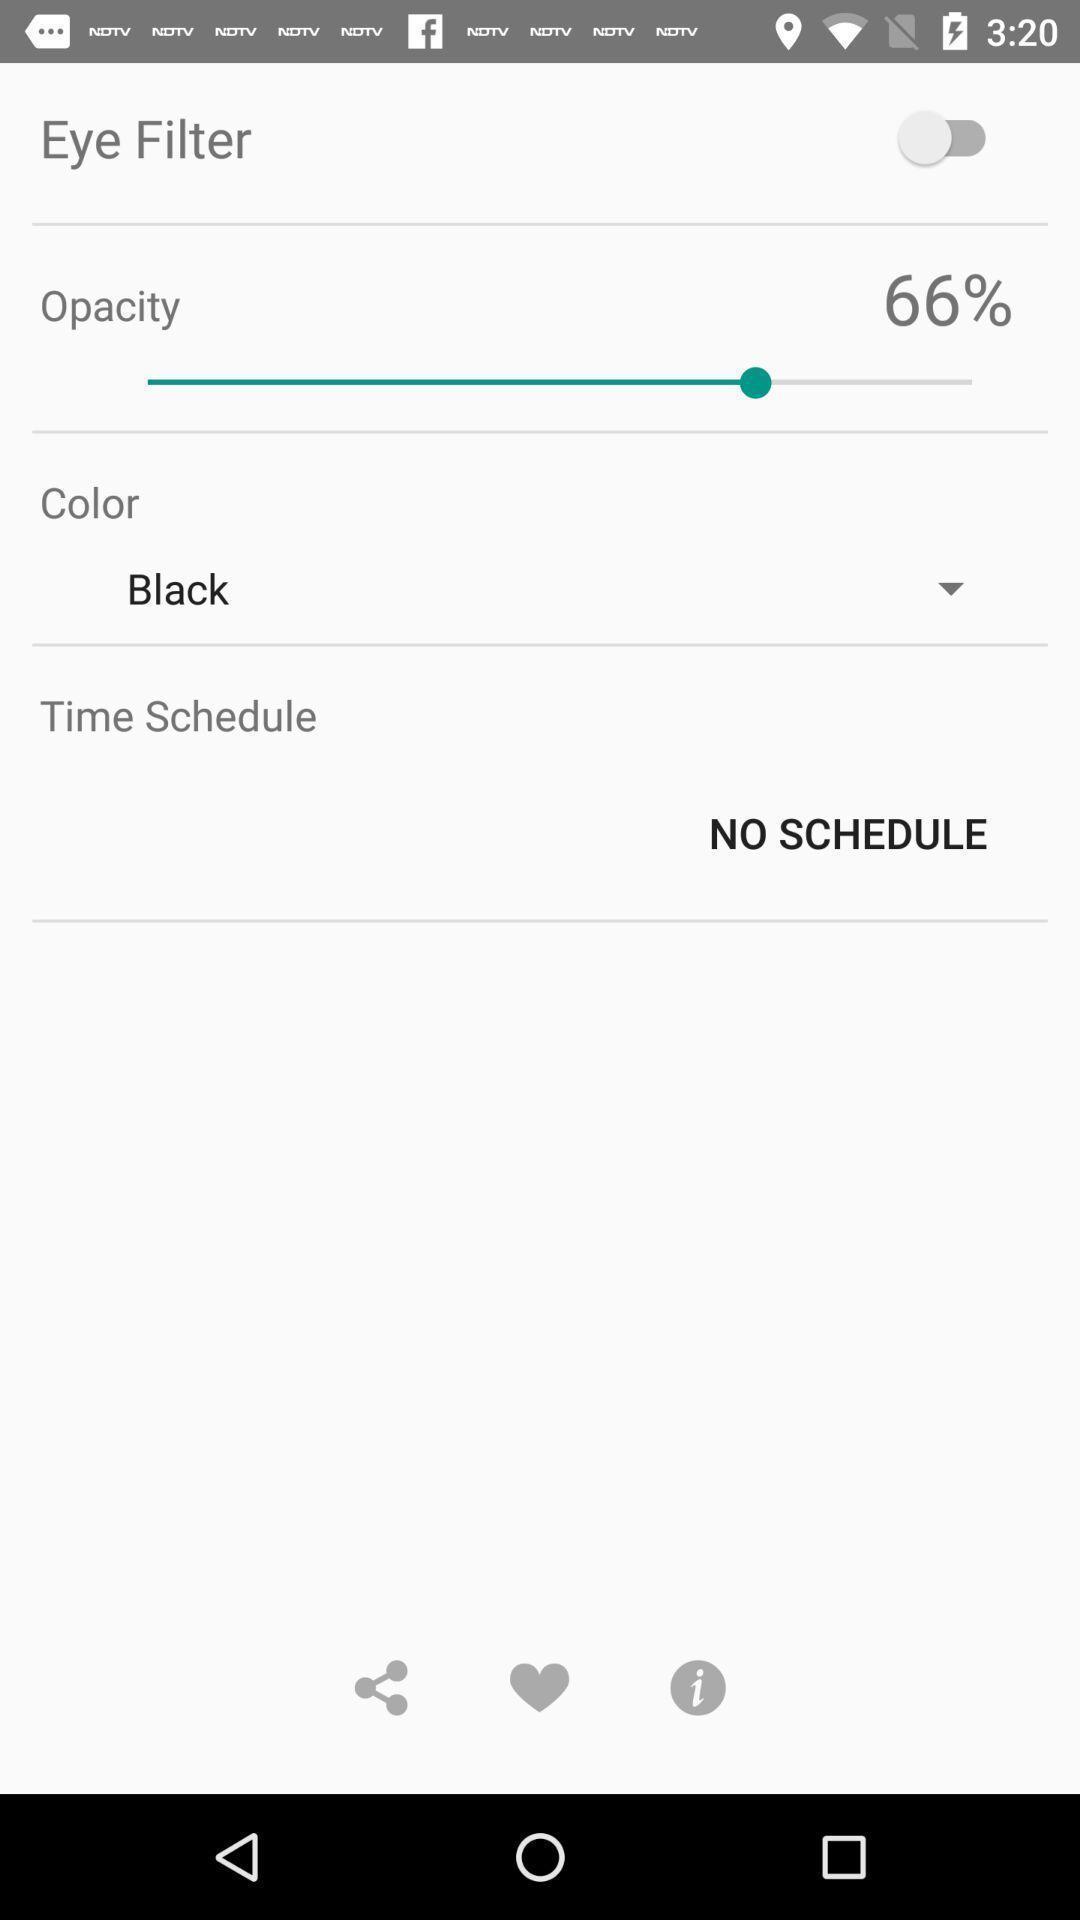What is the overall content of this screenshot? Page displaying options for eye filter. 